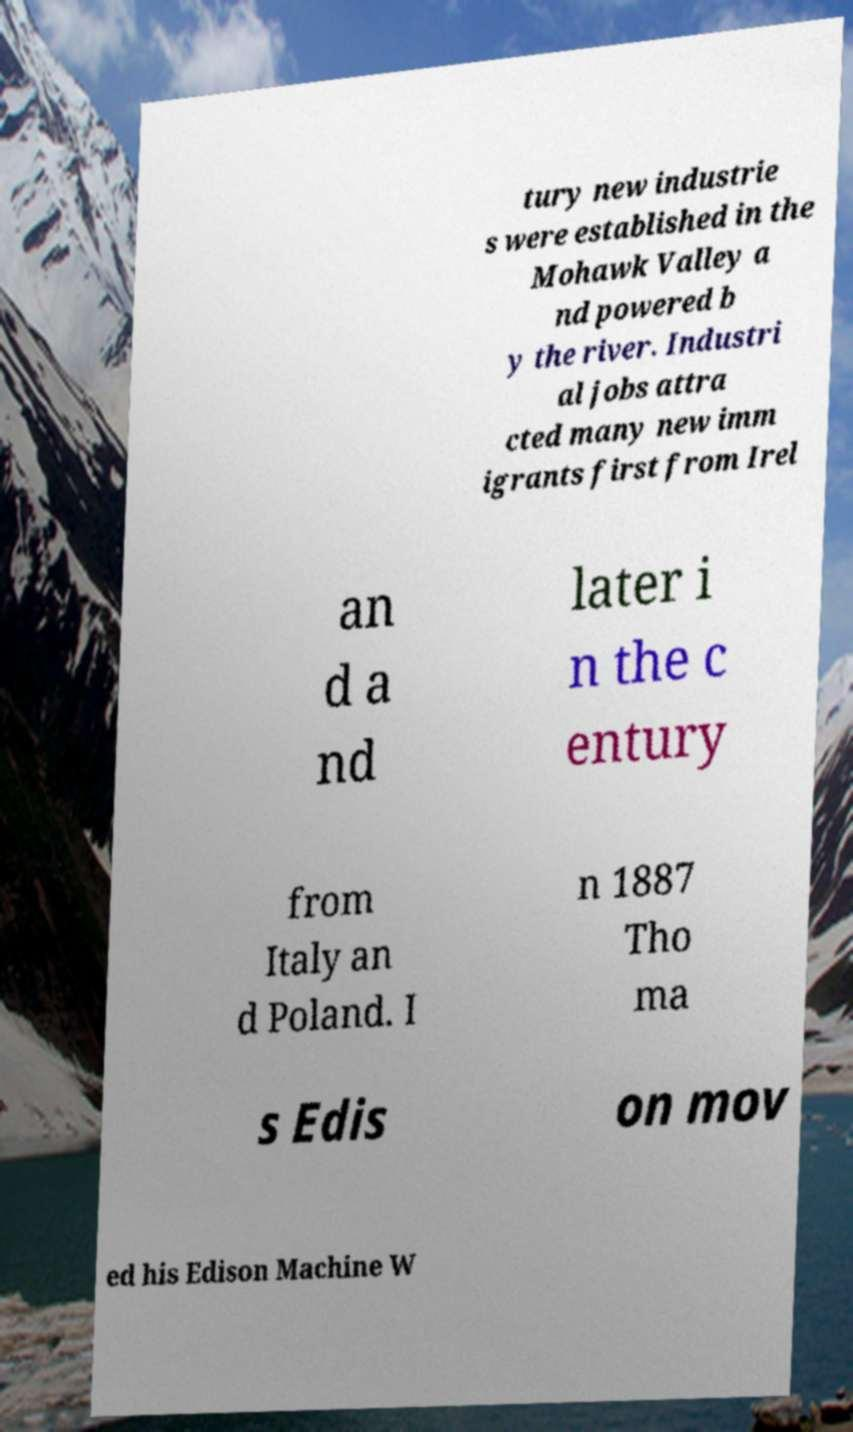I need the written content from this picture converted into text. Can you do that? tury new industrie s were established in the Mohawk Valley a nd powered b y the river. Industri al jobs attra cted many new imm igrants first from Irel an d a nd later i n the c entury from Italy an d Poland. I n 1887 Tho ma s Edis on mov ed his Edison Machine W 